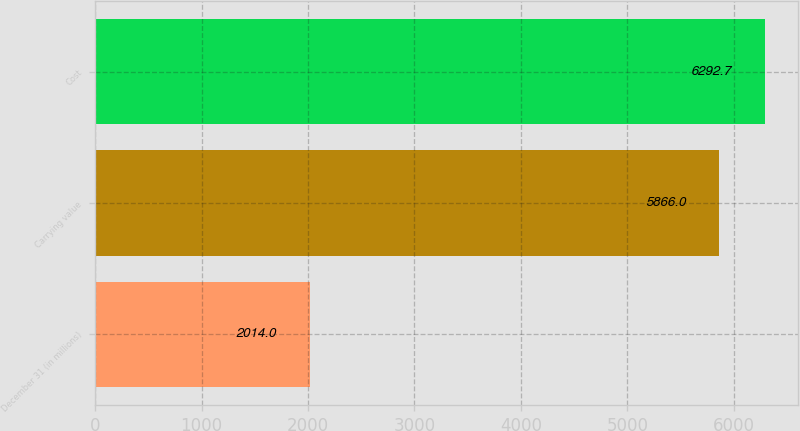Convert chart to OTSL. <chart><loc_0><loc_0><loc_500><loc_500><bar_chart><fcel>December 31 (in millions)<fcel>Carrying value<fcel>Cost<nl><fcel>2014<fcel>5866<fcel>6292.7<nl></chart> 